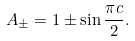Convert formula to latex. <formula><loc_0><loc_0><loc_500><loc_500>A _ { \pm } = 1 \pm \sin \frac { \pi c } { 2 } .</formula> 